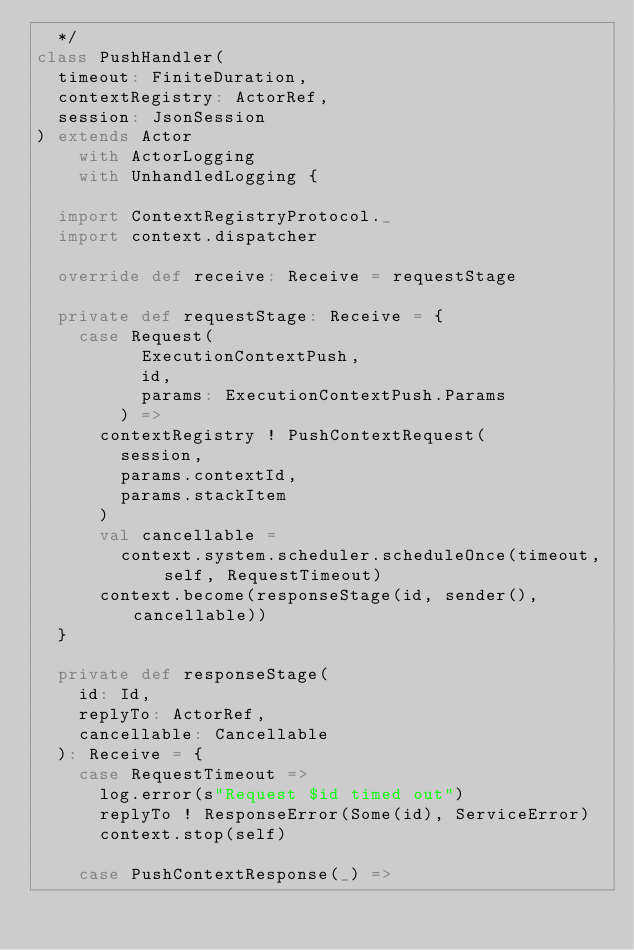<code> <loc_0><loc_0><loc_500><loc_500><_Scala_>  */
class PushHandler(
  timeout: FiniteDuration,
  contextRegistry: ActorRef,
  session: JsonSession
) extends Actor
    with ActorLogging
    with UnhandledLogging {

  import ContextRegistryProtocol._
  import context.dispatcher

  override def receive: Receive = requestStage

  private def requestStage: Receive = {
    case Request(
          ExecutionContextPush,
          id,
          params: ExecutionContextPush.Params
        ) =>
      contextRegistry ! PushContextRequest(
        session,
        params.contextId,
        params.stackItem
      )
      val cancellable =
        context.system.scheduler.scheduleOnce(timeout, self, RequestTimeout)
      context.become(responseStage(id, sender(), cancellable))
  }

  private def responseStage(
    id: Id,
    replyTo: ActorRef,
    cancellable: Cancellable
  ): Receive = {
    case RequestTimeout =>
      log.error(s"Request $id timed out")
      replyTo ! ResponseError(Some(id), ServiceError)
      context.stop(self)

    case PushContextResponse(_) =></code> 